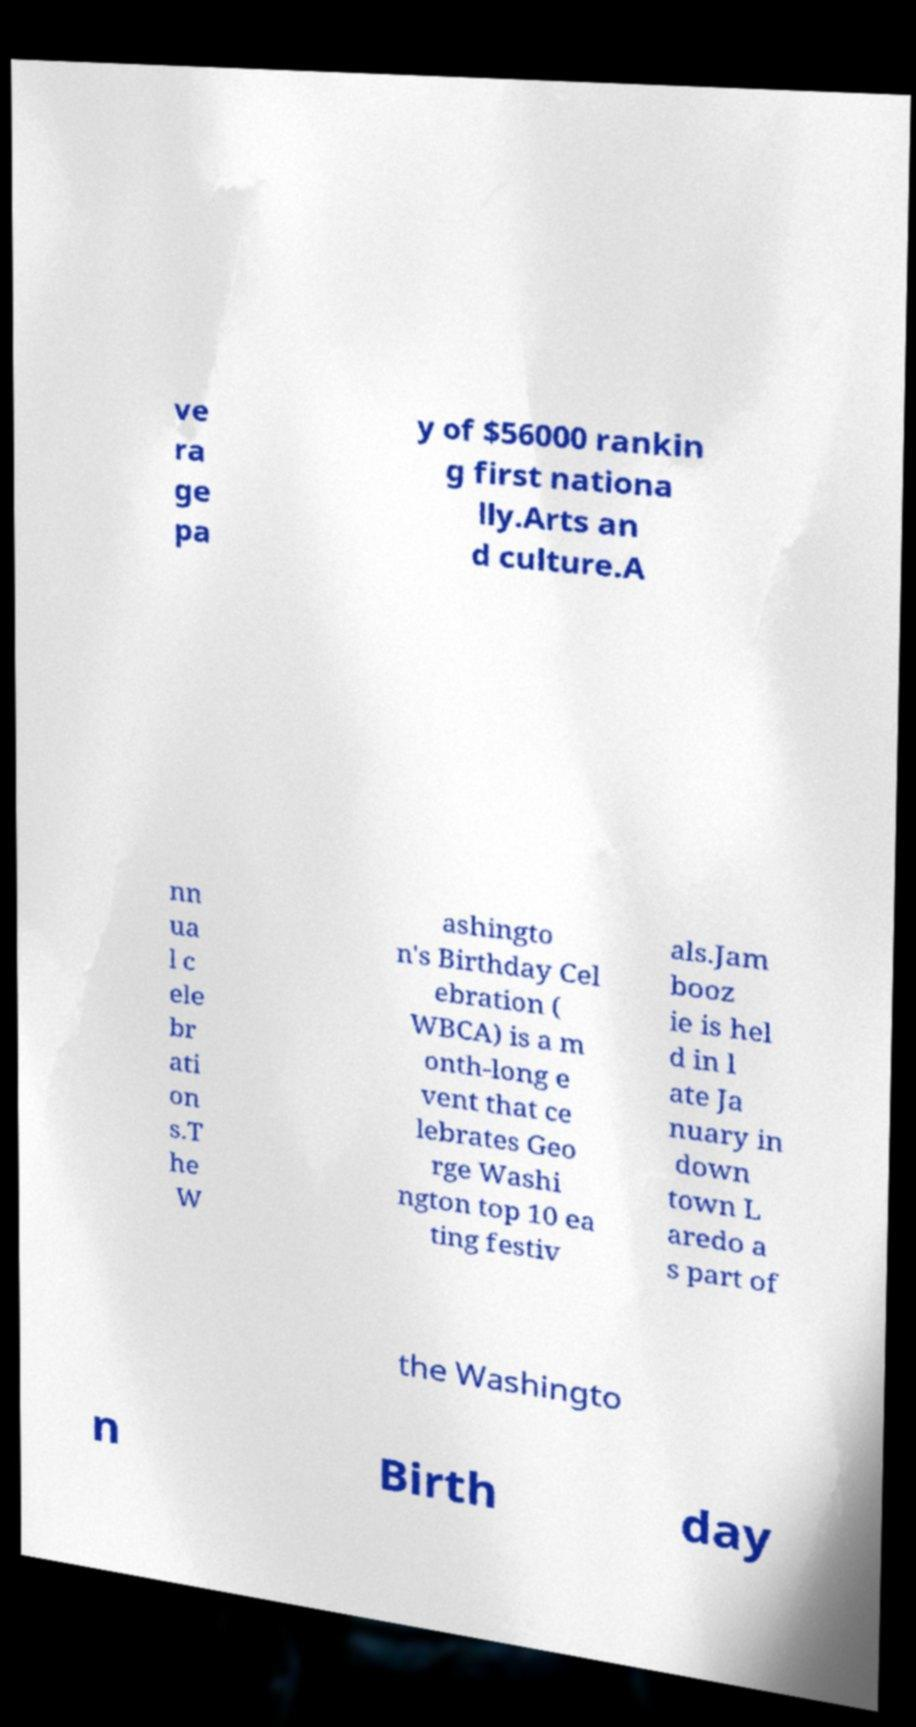For documentation purposes, I need the text within this image transcribed. Could you provide that? ve ra ge pa y of $56000 rankin g first nationa lly.Arts an d culture.A nn ua l c ele br ati on s.T he W ashingto n's Birthday Cel ebration ( WBCA) is a m onth-long e vent that ce lebrates Geo rge Washi ngton top 10 ea ting festiv als.Jam booz ie is hel d in l ate Ja nuary in down town L aredo a s part of the Washingto n Birth day 